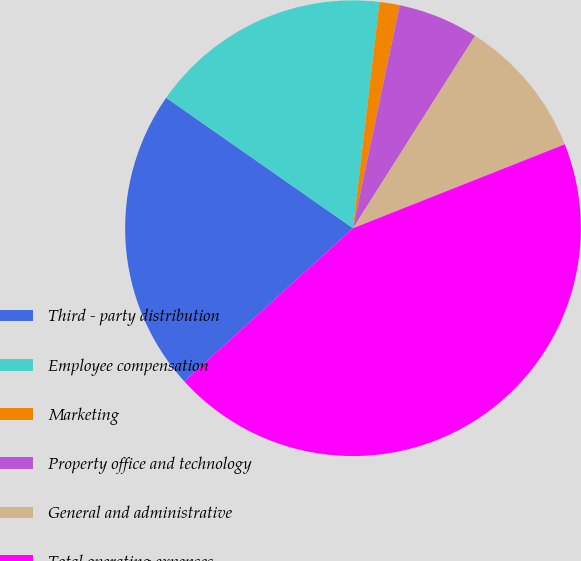Convert chart. <chart><loc_0><loc_0><loc_500><loc_500><pie_chart><fcel>Third - party distribution<fcel>Employee compensation<fcel>Marketing<fcel>Property office and technology<fcel>General and administrative<fcel>Total operating expenses<nl><fcel>21.44%<fcel>17.16%<fcel>1.43%<fcel>5.71%<fcel>10.0%<fcel>44.27%<nl></chart> 